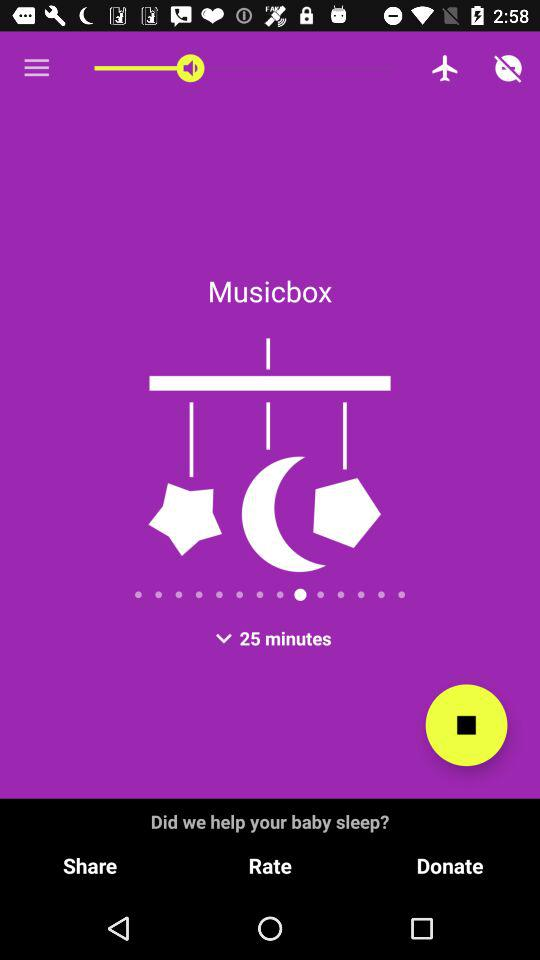How much time is shown? The time shown is 25 minutes. 